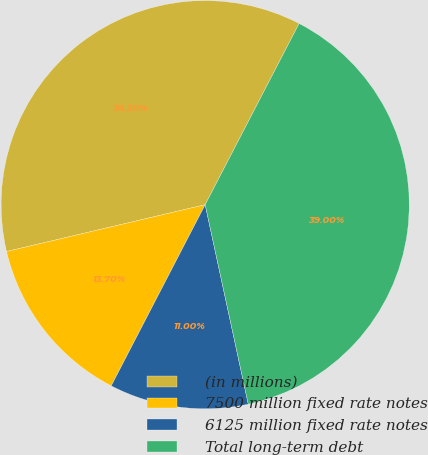<chart> <loc_0><loc_0><loc_500><loc_500><pie_chart><fcel>(in millions)<fcel>7500 million fixed rate notes<fcel>6125 million fixed rate notes<fcel>Total long-term debt<nl><fcel>36.3%<fcel>13.7%<fcel>11.0%<fcel>39.0%<nl></chart> 